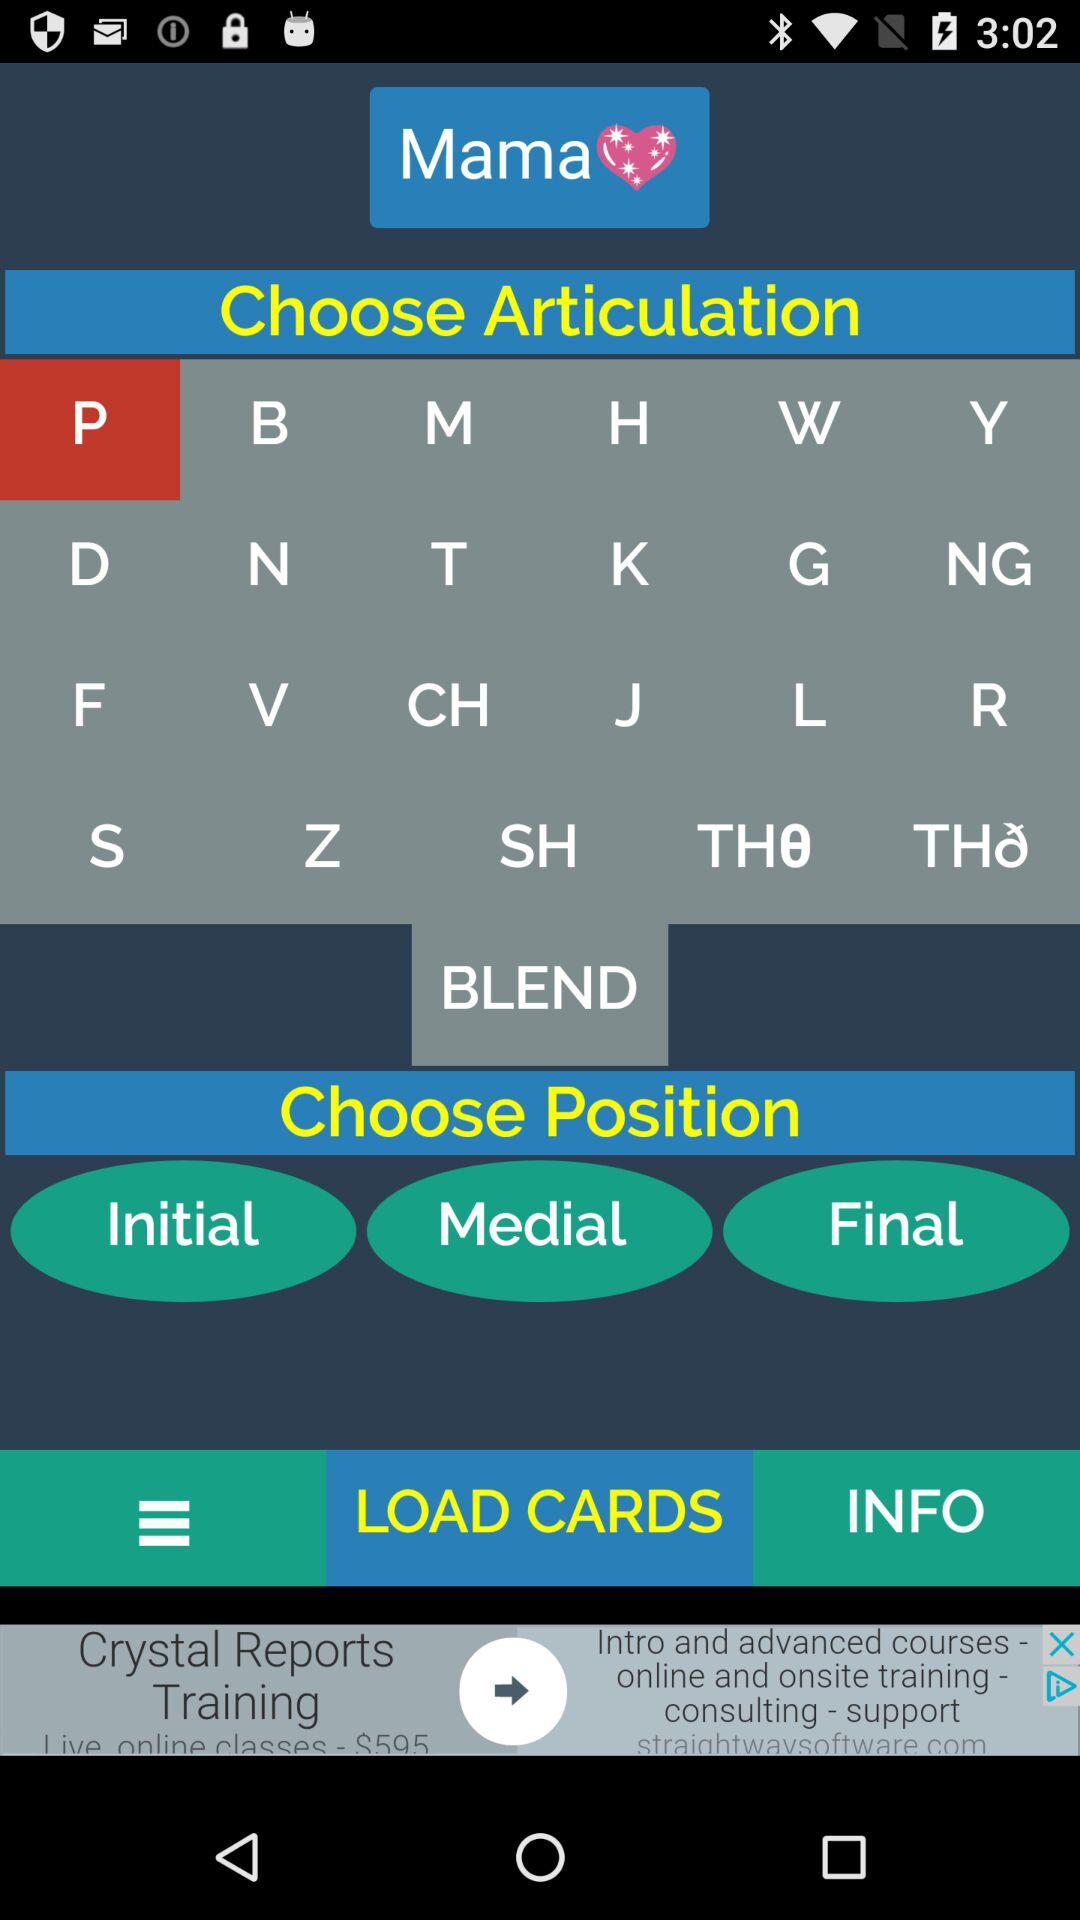Which articulation is selected? The selected articulation is "P". 